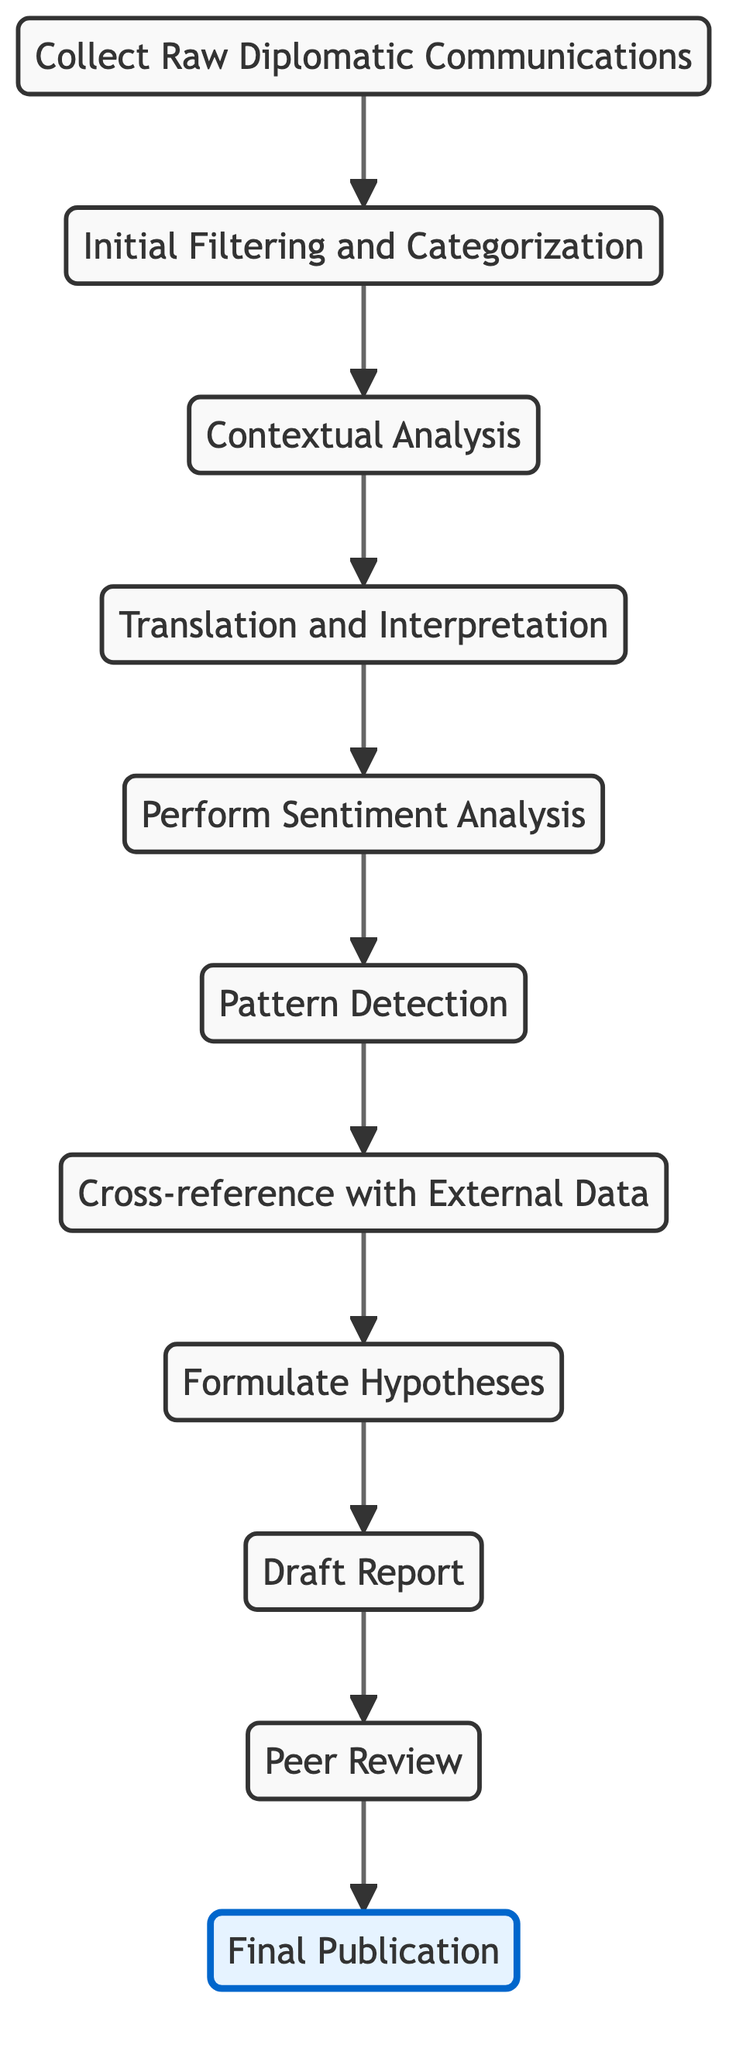What is the first step in the process? The first step is "Collect Raw Diplomatic Communications," which is at the bottom of the flow chart. It indicates the starting point of the analysis process, where all relevant communications are gathered.
Answer: Collect Raw Diplomatic Communications How many total nodes are in the diagram? There are eleven distinct steps or nodes in the flow chart, starting from collecting data to final publication. Each step represents a crucial part of the overall process.
Answer: Eleven Which step follows "Initial Filtering and Categorization"? After "Initial Filtering and Categorization," the next step is "Contextual Analysis." This indicates a progression in the process where filtered information is further analyzed in its specific context.
Answer: Contextual Analysis What is the last step in the analysis process? The last step is "Final Publication." It signifies the completion of the analysis and the dissemination of findings to the intended audience, marking the culmination of the entire process.
Answer: Final Publication What two steps precede "Hypothesis Formulation"? "Cross-reference with External Data" and "Pattern Detection" are the two steps that come before "Hypothesis Formulation." This sequence shows that before forming hypotheses, one must identify patterns and validate findings with external data.
Answer: Cross-reference with External Data, Pattern Detection Which steps involve analyzing the sentiment expressed in the communications? The step that specifically involves analyzing sentiment is "Perform Sentiment Analysis." This step employs natural language processing techniques to assess the feelings expressed in the diplomatic communications.
Answer: Perform Sentiment Analysis How does "Translation and Interpretation" contribute to the overall process? "Translation and Interpretation" is crucial as it ensures that non-English communications are accurately understood and any cultural nuances are properly interpreted. This step allows for a complete understanding before proceeding to sentiment analysis.
Answer: It ensures accurate understanding and interpretation Which step comes immediately after "Draft Report"? The step that follows "Draft Report" is "Peer Review." This indicates that the report is reviewed by experts to ensure its quality before publication.
Answer: Peer Review What is the significance of "Contextual Analysis" in the process? "Contextual Analysis" is significant as it provides a background for the communications being analyzed, considering historical relations and ongoing conflicts. This understanding is critical for accurate interpretation and subsequent analyses.
Answer: Provides background for accurate interpretation 